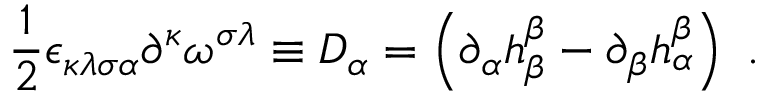<formula> <loc_0><loc_0><loc_500><loc_500>\frac { 1 } { 2 } \epsilon _ { \kappa \lambda \sigma \alpha } \partial ^ { \kappa } \omega ^ { \sigma \lambda } \equiv D _ { \alpha } = \left ( \partial _ { \alpha } h _ { \beta } ^ { \beta } - \partial _ { \beta } h _ { \alpha } ^ { \beta } \right ) \ .</formula> 